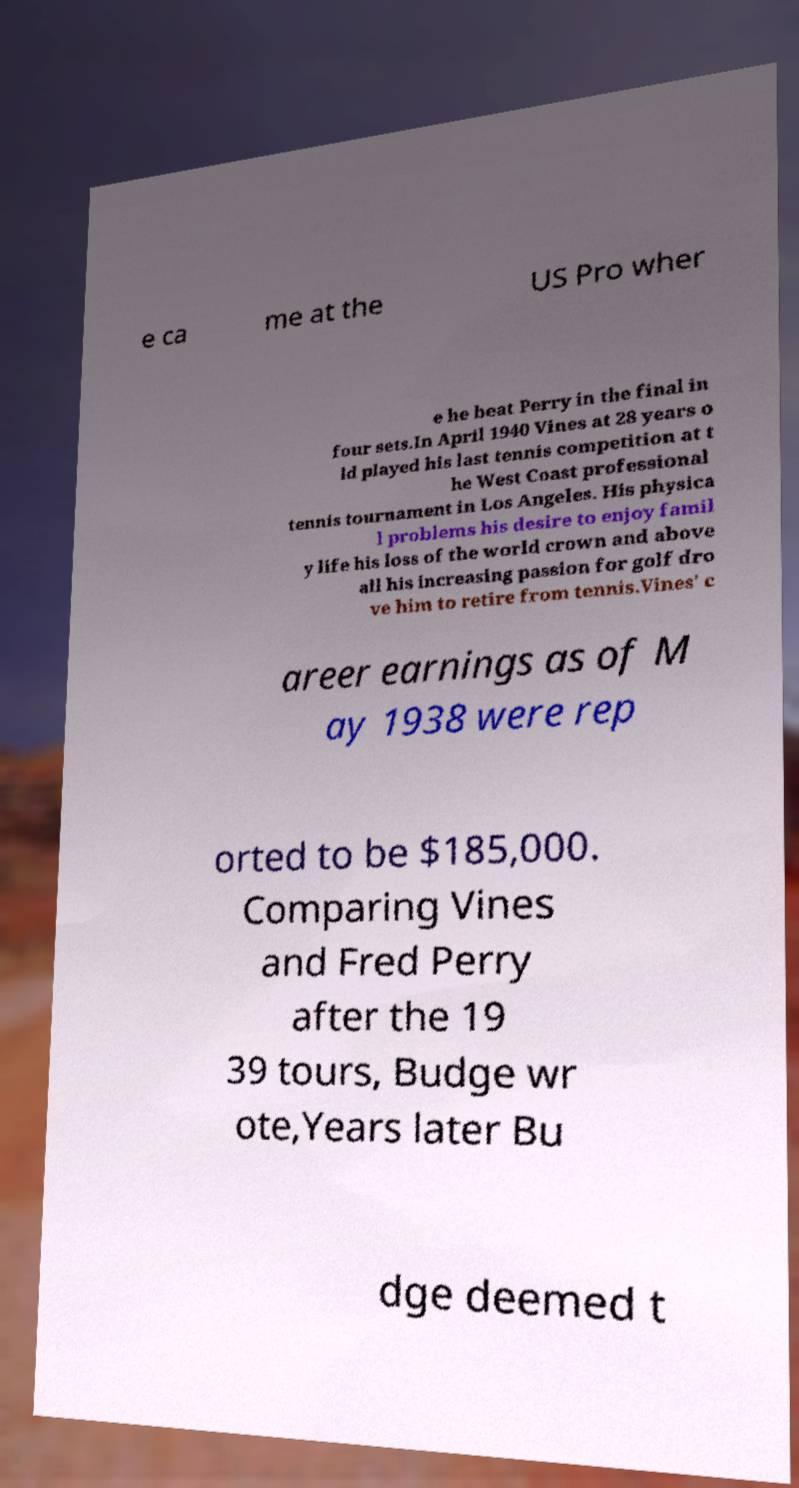Please read and relay the text visible in this image. What does it say? e ca me at the US Pro wher e he beat Perry in the final in four sets.In April 1940 Vines at 28 years o ld played his last tennis competition at t he West Coast professional tennis tournament in Los Angeles. His physica l problems his desire to enjoy famil y life his loss of the world crown and above all his increasing passion for golf dro ve him to retire from tennis.Vines' c areer earnings as of M ay 1938 were rep orted to be $185,000. Comparing Vines and Fred Perry after the 19 39 tours, Budge wr ote,Years later Bu dge deemed t 